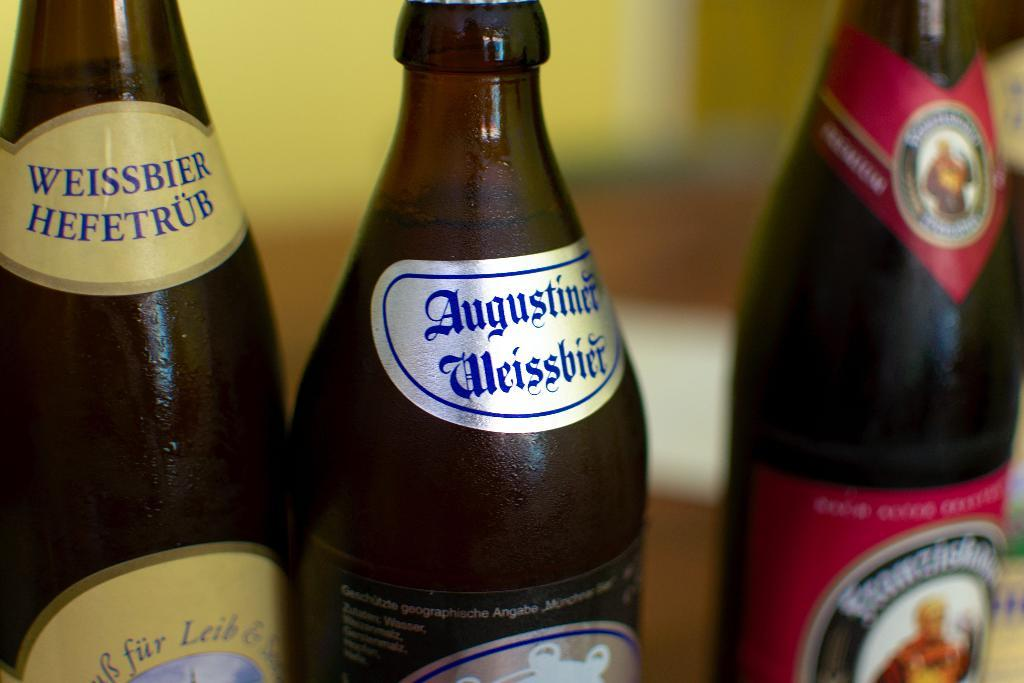<image>
Create a compact narrative representing the image presented. a bottle that says augustine on the front 